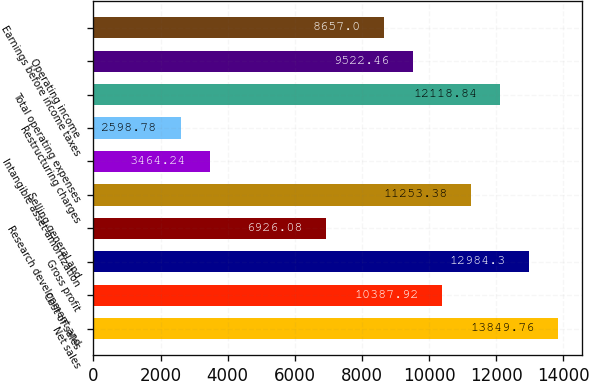<chart> <loc_0><loc_0><loc_500><loc_500><bar_chart><fcel>Net sales<fcel>Cost of sales<fcel>Gross profit<fcel>Research development and<fcel>Selling general and<fcel>Intangible asset amortization<fcel>Restructuring charges<fcel>Total operating expenses<fcel>Operating income<fcel>Earnings before income taxes<nl><fcel>13849.8<fcel>10387.9<fcel>12984.3<fcel>6926.08<fcel>11253.4<fcel>3464.24<fcel>2598.78<fcel>12118.8<fcel>9522.46<fcel>8657<nl></chart> 